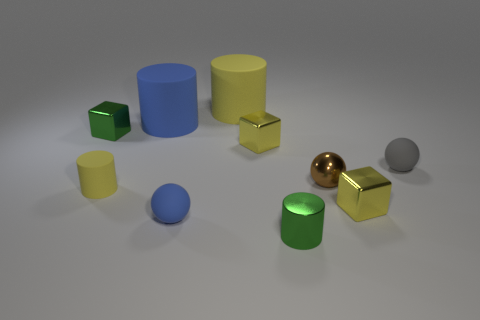Subtract 1 cylinders. How many cylinders are left? 3 Subtract all balls. How many objects are left? 7 Subtract all metallic cubes. Subtract all big yellow objects. How many objects are left? 6 Add 2 tiny brown shiny things. How many tiny brown shiny things are left? 3 Add 5 small blue balls. How many small blue balls exist? 6 Subtract 1 green cubes. How many objects are left? 9 